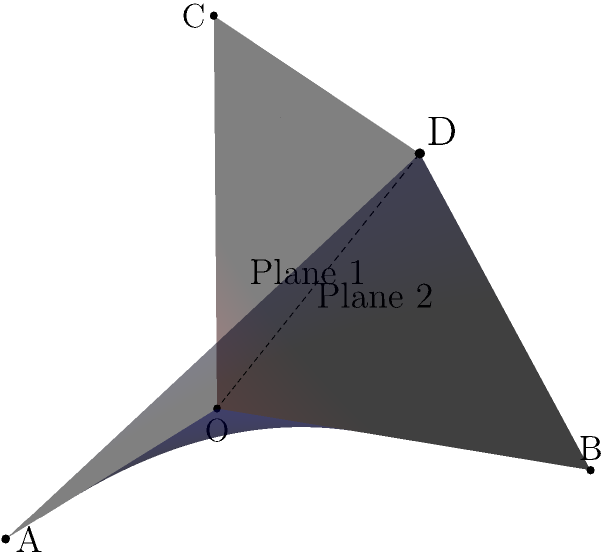In a cutting-edge geometric handbag design, two intersecting planes form the main structure. Plane 1 is defined by points O, A, and B, while Plane 2 is defined by points O, B, and C. If OA = OB = OC = 1 unit, what is the angle between these two planes? To find the angle between two planes, we need to follow these steps:

1) First, we need to find the normal vectors of both planes:

   For Plane 1 (OAB): $\vec{n_1} = \overrightarrow{OA} \times \overrightarrow{OB} = (1,0,0) \times (0,1,0) = (0,0,1)$
   For Plane 2 (OBC): $\vec{n_2} = \overrightarrow{OB} \times \overrightarrow{OC} = (0,1,0) \times (0,0,1) = (1,0,0)$

2) The angle between the planes is the same as the angle between their normal vectors. We can find this using the dot product formula:

   $\cos \theta = \frac{\vec{n_1} \cdot \vec{n_2}}{|\vec{n_1}||\vec{n_2}|}$

3) Calculate the dot product:
   $\vec{n_1} \cdot \vec{n_2} = (0,0,1) \cdot (1,0,0) = 0$

4) Calculate the magnitudes:
   $|\vec{n_1}| = |\vec{n_2}| = 1$

5) Substitute into the formula:
   $\cos \theta = \frac{0}{1 \cdot 1} = 0$

6) Solve for $\theta$:
   $\theta = \arccos(0) = 90°$

Therefore, the angle between the two planes is 90°.
Answer: 90° 